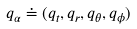<formula> <loc_0><loc_0><loc_500><loc_500>q _ { \alpha } \doteq ( q _ { t } , q _ { r } , q _ { \theta } , q _ { \phi } )</formula> 